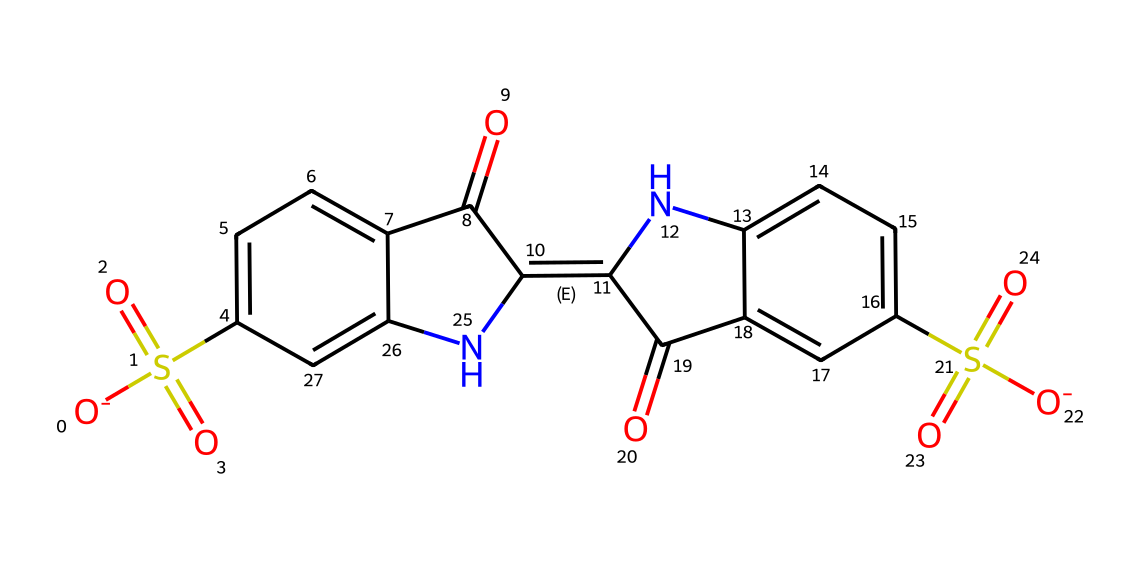What is the chemical name of this structure? The SMILES notation corresponds to a well-known organic compound, specifically the dye commonly referred to as indigo carmine. This name can be verified through chemical databases and literature.
Answer: indigo carmine How many carbon atoms are present in the structure? To determine the number of carbon atoms, I will count each distinct carbon in the structural formula provided. The visual representation reveals a total of 17 carbon atoms throughout the structure.
Answer: 17 What type of functional groups are present in indigo carmine? By analyzing the structure, we notice the presence of sulfonic acid (–SO3H) groups, which can be identified by the sulfur atom bonded to three oxygen atoms. Also, there are ketone groups (C=O) visible.
Answer: sulfonic acid and ketones Which part of the structure indicates its solubility in water? The sulfonic acid groups (–SO3H) are highly polar and contribute to the dye's solubility in water, as polar functional groups increase interaction with water molecules.
Answer: sulfonic acid groups What kind of dye is indigo carmine classified as? Indigo carmine is primarily used as an acid dye due to the presence of sulfonic acid groups that facilitate its use in various acidic environments.
Answer: acid dye How many nitrogen atoms are in the structure? Counting the nitrogen atoms in the chemical structure reveals there are 2 nitrogen atoms present, located within the aromatic rings.
Answer: 2 What color does indigo carmine produce in aqueous solution? The color of indigo carmine when dissolved in water is blue, a characteristic feature of this dye. This can be confirmed through practical experiments and literature.
Answer: blue 